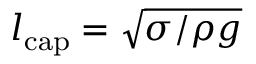Convert formula to latex. <formula><loc_0><loc_0><loc_500><loc_500>l _ { c a p } = \sqrt { \sigma / \rho g }</formula> 